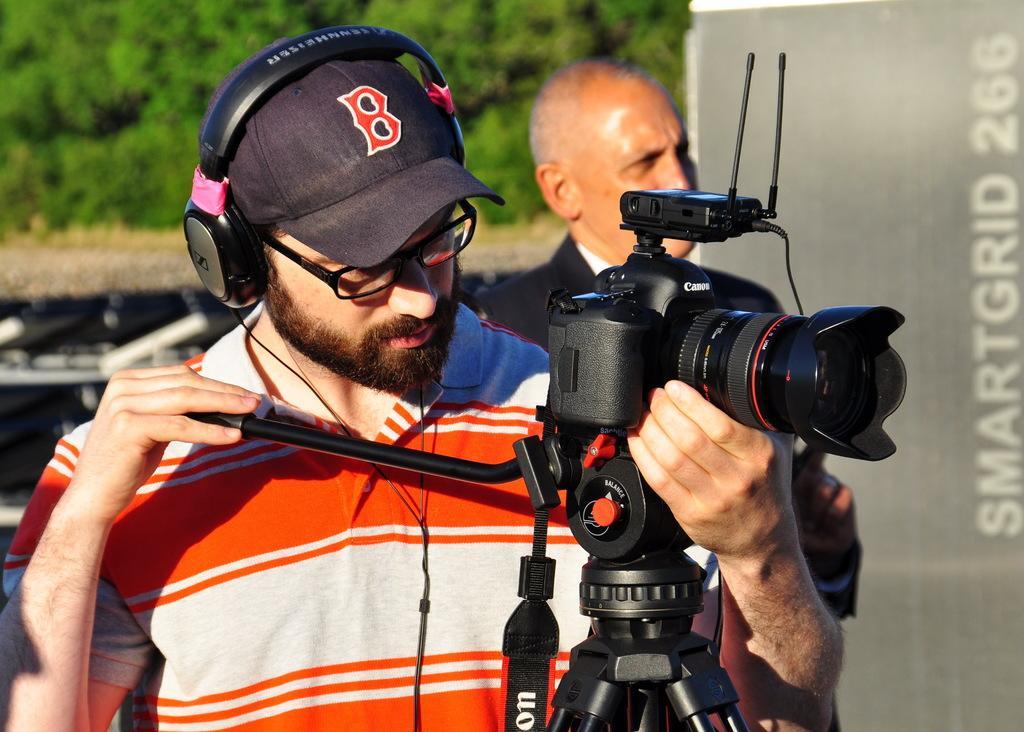In one or two sentences, can you explain what this image depicts? In the image there is a man holding a camera wearing a headphone and background of him there are trees. 